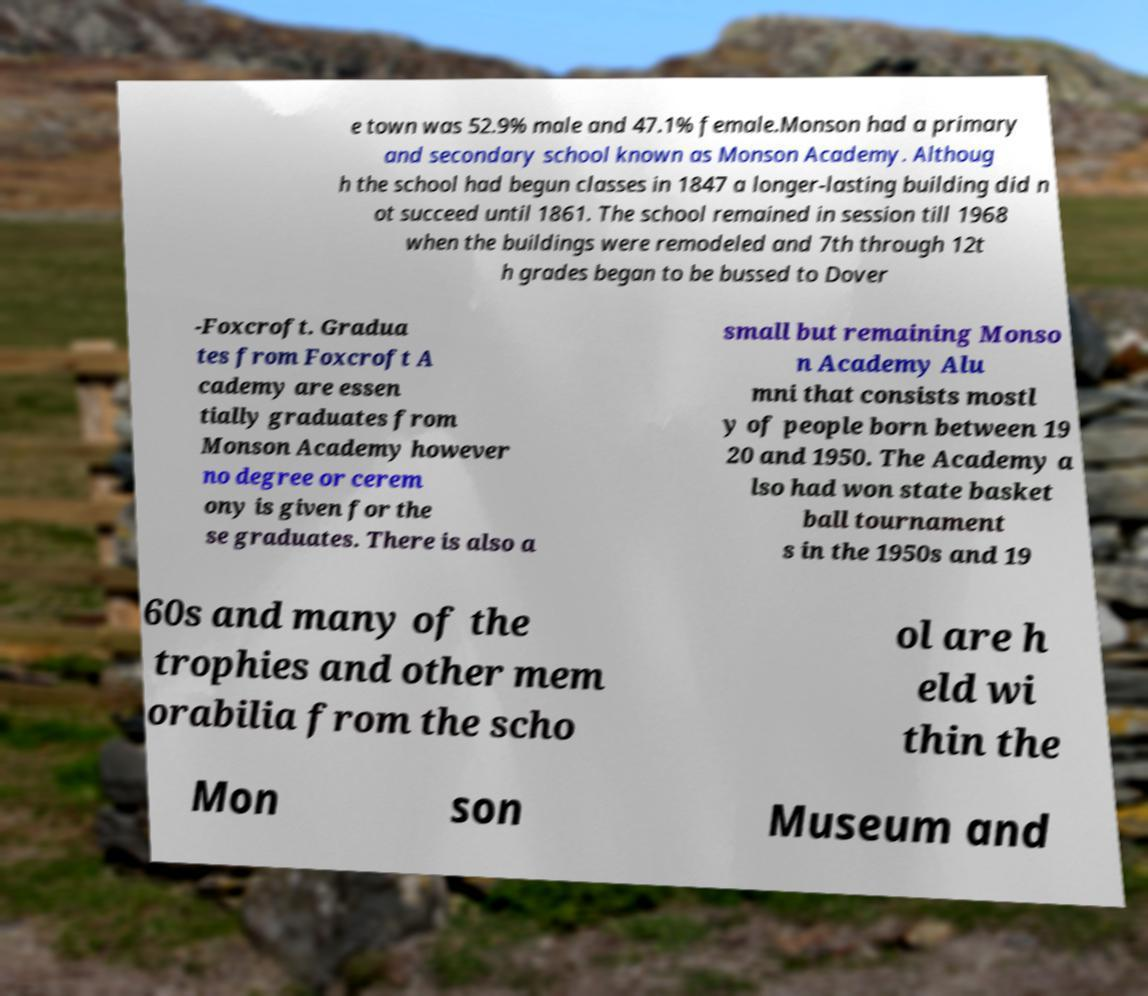Please read and relay the text visible in this image. What does it say? e town was 52.9% male and 47.1% female.Monson had a primary and secondary school known as Monson Academy. Althoug h the school had begun classes in 1847 a longer-lasting building did n ot succeed until 1861. The school remained in session till 1968 when the buildings were remodeled and 7th through 12t h grades began to be bussed to Dover -Foxcroft. Gradua tes from Foxcroft A cademy are essen tially graduates from Monson Academy however no degree or cerem ony is given for the se graduates. There is also a small but remaining Monso n Academy Alu mni that consists mostl y of people born between 19 20 and 1950. The Academy a lso had won state basket ball tournament s in the 1950s and 19 60s and many of the trophies and other mem orabilia from the scho ol are h eld wi thin the Mon son Museum and 